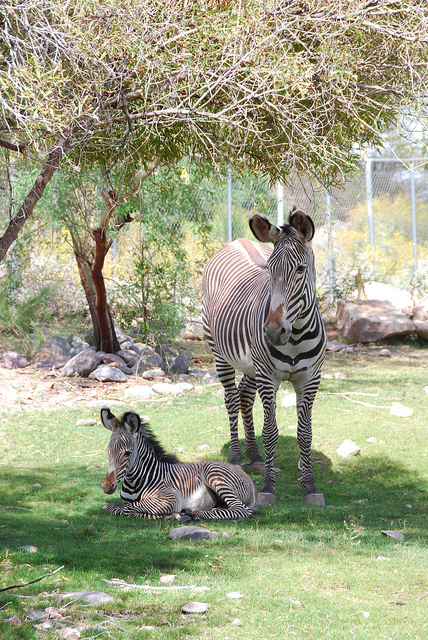<image>What are the zebras doing in this picture? I am not sure what the zebras are doing in this picture. They could be relaxing, resting, standing, laying, or eating. What are the zebras doing in this picture? I am not sure what the zebras are doing in the picture. It can be seen that they are either relaxing, laying down, sitting, standing, or eating. 